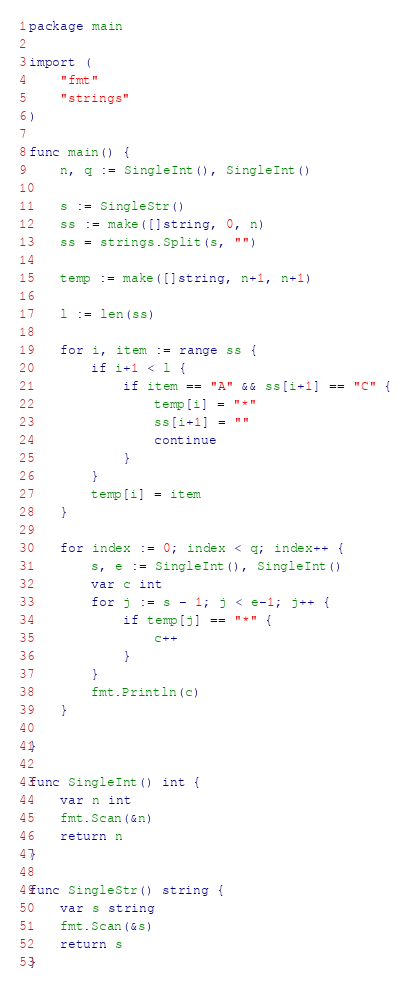Convert code to text. <code><loc_0><loc_0><loc_500><loc_500><_Go_>package main

import (
	"fmt"
	"strings"
)

func main() {
	n, q := SingleInt(), SingleInt()

	s := SingleStr()
	ss := make([]string, 0, n)
	ss = strings.Split(s, "")

	temp := make([]string, n+1, n+1)

	l := len(ss)

	for i, item := range ss {
		if i+1 < l {
			if item == "A" && ss[i+1] == "C" {
				temp[i] = "*"
				ss[i+1] = ""
				continue
			}
		}
		temp[i] = item
	}

	for index := 0; index < q; index++ {
		s, e := SingleInt(), SingleInt()
		var c int
		for j := s - 1; j < e-1; j++ {
			if temp[j] == "*" {
				c++
			}
		}
		fmt.Println(c)
	}

}

func SingleInt() int {
	var n int
	fmt.Scan(&n)
	return n
}

func SingleStr() string {
	var s string
	fmt.Scan(&s)
	return s
}
</code> 